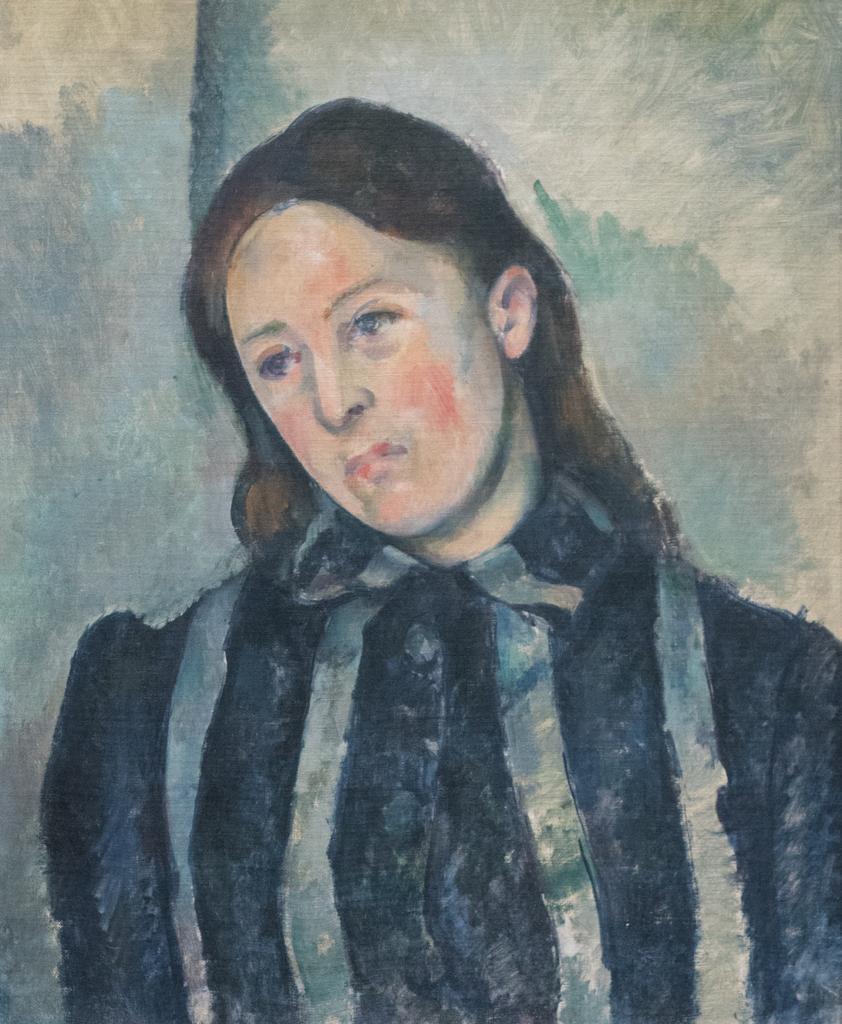Could you give a brief overview of what you see in this image? In this picture I can see painting of a woman on the wall. 